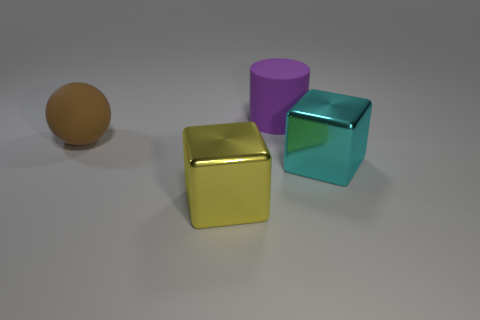Is there anything else that is the same shape as the purple matte object?
Make the answer very short. No. What size is the object that is made of the same material as the large cyan block?
Provide a succinct answer. Large. Are there more big cyan objects than purple blocks?
Provide a succinct answer. Yes. What color is the big cube that is right of the big yellow shiny object?
Offer a very short reply. Cyan. What size is the thing that is on the right side of the rubber sphere and left of the purple cylinder?
Offer a very short reply. Large. How many green things are the same size as the yellow object?
Provide a short and direct response. 0. What material is the large yellow object that is the same shape as the big cyan shiny thing?
Make the answer very short. Metal. Do the yellow metal thing and the large purple object have the same shape?
Offer a very short reply. No. What number of brown things are on the right side of the big cylinder?
Make the answer very short. 0. What shape is the big purple thing behind the large thing to the right of the cylinder?
Your answer should be very brief. Cylinder. 